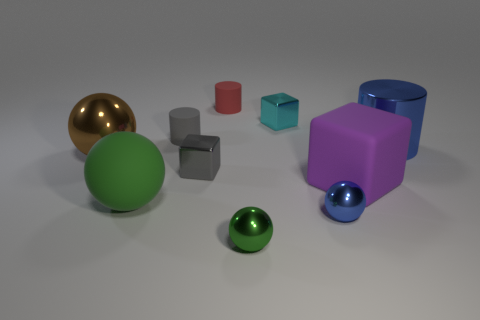Subtract all cylinders. How many objects are left? 7 Add 5 tiny brown metallic blocks. How many tiny brown metallic blocks exist? 5 Subtract 0 brown cylinders. How many objects are left? 10 Subtract all small red cylinders. Subtract all large matte objects. How many objects are left? 7 Add 4 blue cylinders. How many blue cylinders are left? 5 